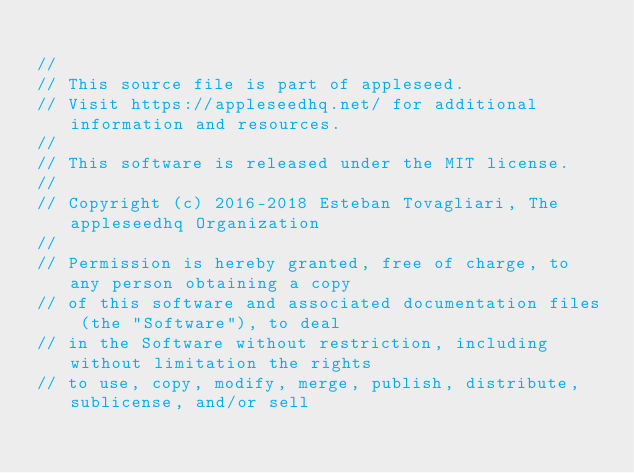<code> <loc_0><loc_0><loc_500><loc_500><_C++_>
//
// This source file is part of appleseed.
// Visit https://appleseedhq.net/ for additional information and resources.
//
// This software is released under the MIT license.
//
// Copyright (c) 2016-2018 Esteban Tovagliari, The appleseedhq Organization
//
// Permission is hereby granted, free of charge, to any person obtaining a copy
// of this software and associated documentation files (the "Software"), to deal
// in the Software without restriction, including without limitation the rights
// to use, copy, modify, merge, publish, distribute, sublicense, and/or sell</code> 